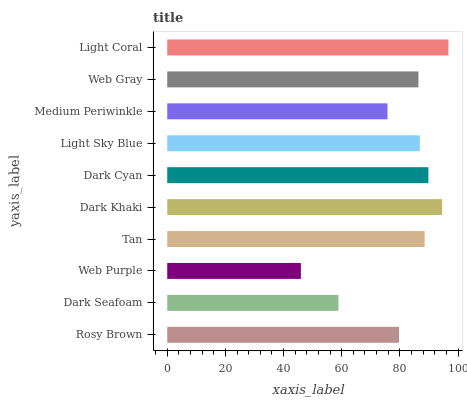Is Web Purple the minimum?
Answer yes or no. Yes. Is Light Coral the maximum?
Answer yes or no. Yes. Is Dark Seafoam the minimum?
Answer yes or no. No. Is Dark Seafoam the maximum?
Answer yes or no. No. Is Rosy Brown greater than Dark Seafoam?
Answer yes or no. Yes. Is Dark Seafoam less than Rosy Brown?
Answer yes or no. Yes. Is Dark Seafoam greater than Rosy Brown?
Answer yes or no. No. Is Rosy Brown less than Dark Seafoam?
Answer yes or no. No. Is Light Sky Blue the high median?
Answer yes or no. Yes. Is Web Gray the low median?
Answer yes or no. Yes. Is Dark Khaki the high median?
Answer yes or no. No. Is Dark Khaki the low median?
Answer yes or no. No. 